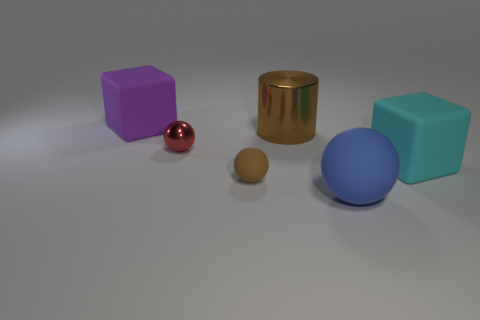Add 2 large cylinders. How many objects exist? 8 Subtract all purple blocks. Subtract all blue spheres. How many blocks are left? 1 Subtract all blocks. How many objects are left? 4 Subtract 0 red blocks. How many objects are left? 6 Subtract all tiny brown balls. Subtract all small brown matte spheres. How many objects are left? 4 Add 1 cyan objects. How many cyan objects are left? 2 Add 3 large balls. How many large balls exist? 4 